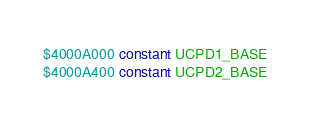<code> <loc_0><loc_0><loc_500><loc_500><_Forth_>$4000A000 constant UCPD1_BASE
$4000A400 constant UCPD2_BASE
</code> 